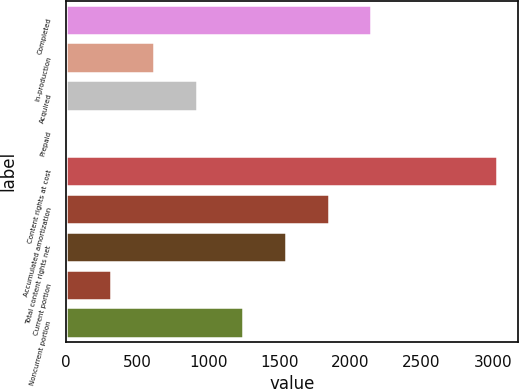<chart> <loc_0><loc_0><loc_500><loc_500><bar_chart><fcel>Completed<fcel>In-production<fcel>Acquired<fcel>Prepaid<fcel>Content rights at cost<fcel>Accumulated amortization<fcel>Total content rights net<fcel>Current portion<fcel>Noncurrent portion<nl><fcel>2148.3<fcel>621.2<fcel>922.3<fcel>19<fcel>3030<fcel>1847.2<fcel>1546.1<fcel>320.1<fcel>1245<nl></chart> 